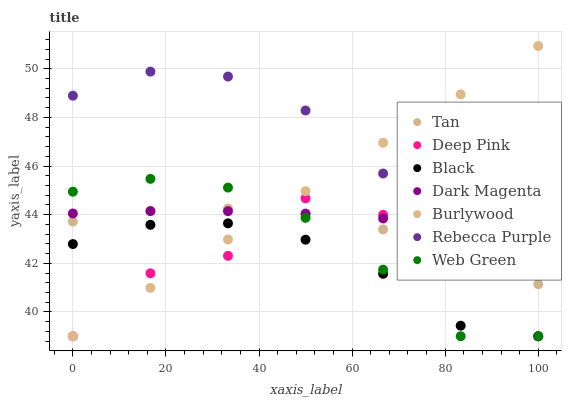Does Black have the minimum area under the curve?
Answer yes or no. Yes. Does Rebecca Purple have the maximum area under the curve?
Answer yes or no. Yes. Does Dark Magenta have the minimum area under the curve?
Answer yes or no. No. Does Dark Magenta have the maximum area under the curve?
Answer yes or no. No. Is Burlywood the smoothest?
Answer yes or no. Yes. Is Deep Pink the roughest?
Answer yes or no. Yes. Is Dark Magenta the smoothest?
Answer yes or no. No. Is Dark Magenta the roughest?
Answer yes or no. No. Does Deep Pink have the lowest value?
Answer yes or no. Yes. Does Dark Magenta have the lowest value?
Answer yes or no. No. Does Burlywood have the highest value?
Answer yes or no. Yes. Does Dark Magenta have the highest value?
Answer yes or no. No. Is Black less than Dark Magenta?
Answer yes or no. Yes. Is Tan greater than Black?
Answer yes or no. Yes. Does Burlywood intersect Web Green?
Answer yes or no. Yes. Is Burlywood less than Web Green?
Answer yes or no. No. Is Burlywood greater than Web Green?
Answer yes or no. No. Does Black intersect Dark Magenta?
Answer yes or no. No. 